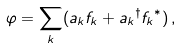Convert formula to latex. <formula><loc_0><loc_0><loc_500><loc_500>\varphi = { \sum _ { k } } ( { a _ { k } } { f _ { k } } + { a _ { k } } ^ { \dagger } { f _ { k } } ^ { \ast } ) \, ,</formula> 